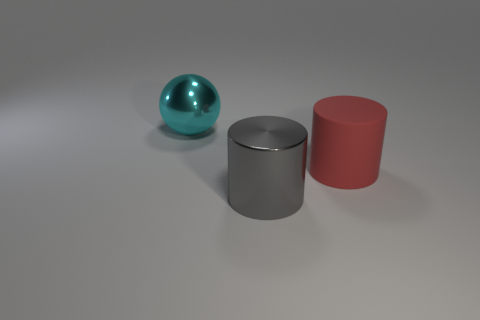How many other rubber objects have the same shape as the large gray object?
Provide a short and direct response. 1. Are there an equal number of cyan spheres to the left of the cyan ball and cyan metallic spheres?
Your response must be concise. No. Is there anything else that has the same size as the cyan metal ball?
Make the answer very short. Yes. The cyan shiny object that is the same size as the red cylinder is what shape?
Offer a very short reply. Sphere. Is there another big object of the same shape as the big red rubber thing?
Your response must be concise. Yes. There is a large red matte cylinder that is right of the big metal object that is in front of the cyan metallic ball; is there a large gray shiny object that is on the left side of it?
Your answer should be very brief. Yes. Is the number of cyan spheres that are behind the large cyan thing greater than the number of shiny spheres left of the big red object?
Offer a very short reply. No. There is a gray object that is the same size as the metallic sphere; what is its material?
Provide a short and direct response. Metal. How many tiny things are either yellow cylinders or red cylinders?
Ensure brevity in your answer.  0. Is the shape of the large red rubber thing the same as the gray shiny object?
Your response must be concise. Yes. 